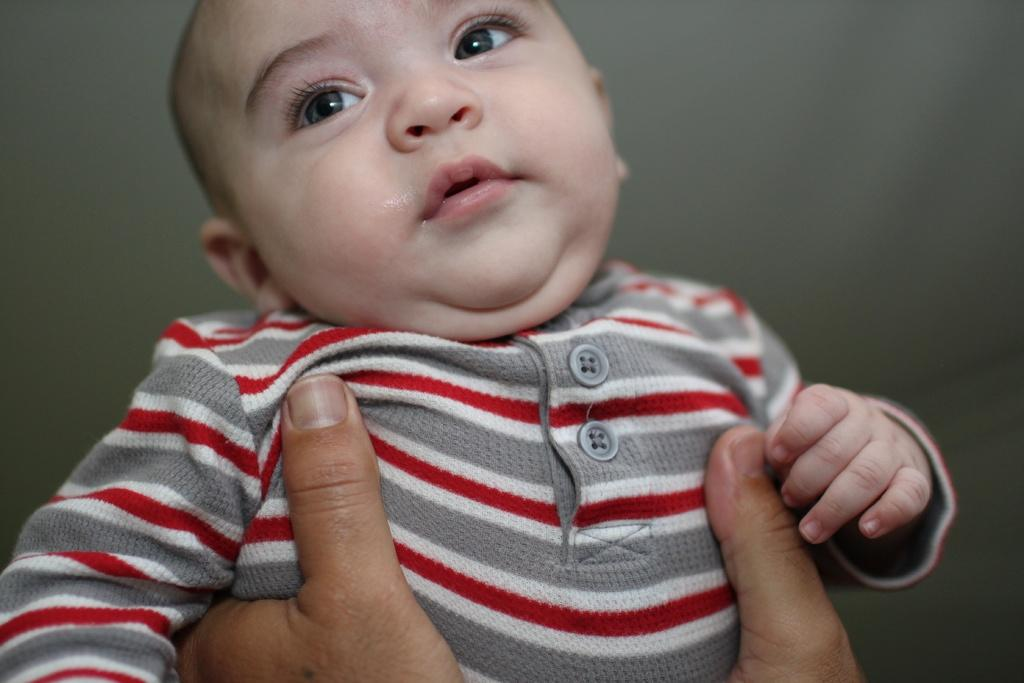What is the focus of the image? The image is zoomed in on a kid. What is the kid wearing? The kid is wearing a t-shirt. Can you describe the position of the kid in the image? The kid is in the center of the image. What is happening in the foreground of the image? There are hands of a person holding the kid in the foreground. What type of shade is covering the amusement park in the image? There is no shade or amusement park present in the image; it features a kid in the center with hands holding them in the foreground. How does the fog affect the visibility in the image? There is no fog present in the image, so its effect on visibility cannot be determined. 